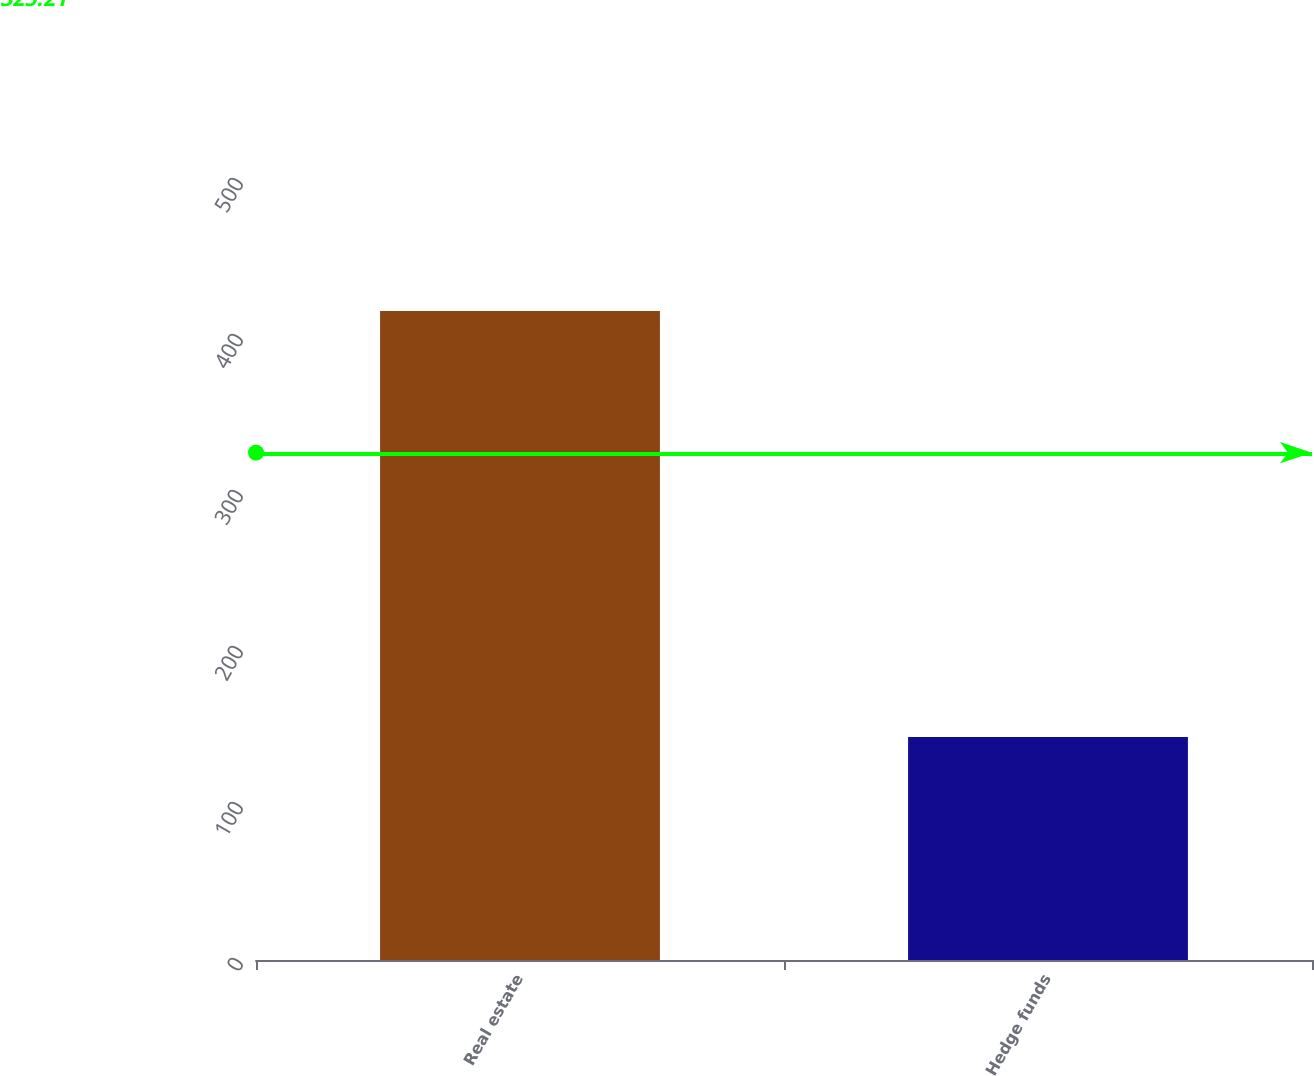Convert chart to OTSL. <chart><loc_0><loc_0><loc_500><loc_500><bar_chart><fcel>Real estate<fcel>Hedge funds<nl><fcel>416<fcel>143<nl></chart> 